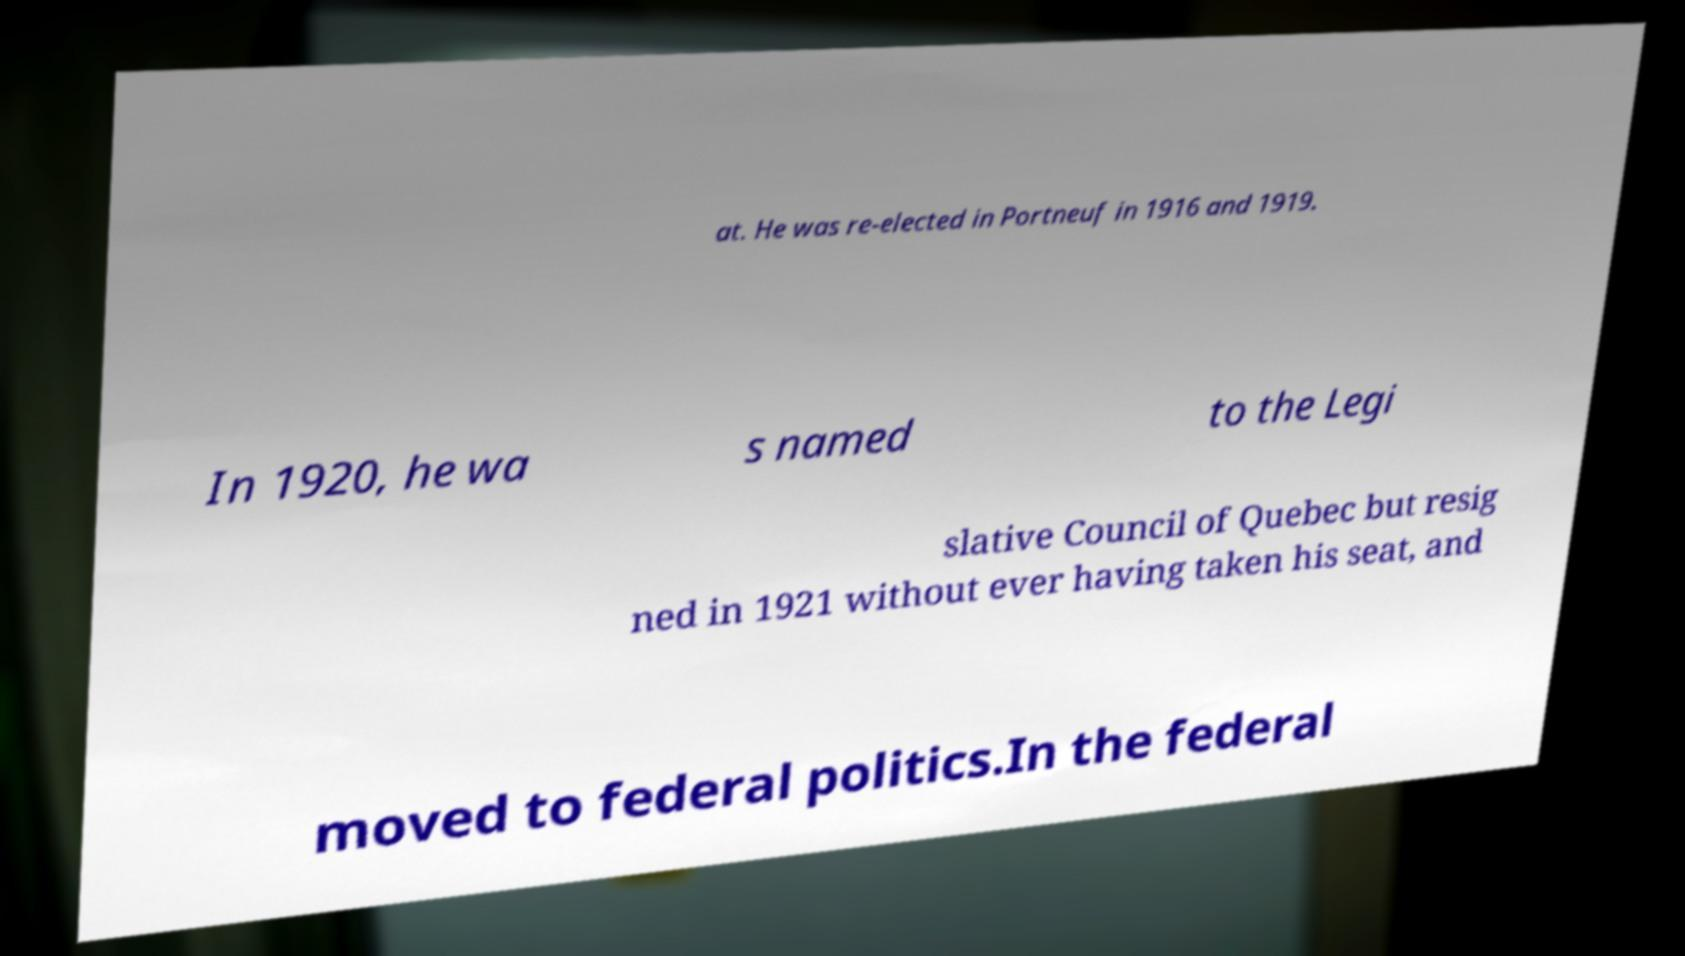Could you assist in decoding the text presented in this image and type it out clearly? at. He was re-elected in Portneuf in 1916 and 1919. In 1920, he wa s named to the Legi slative Council of Quebec but resig ned in 1921 without ever having taken his seat, and moved to federal politics.In the federal 